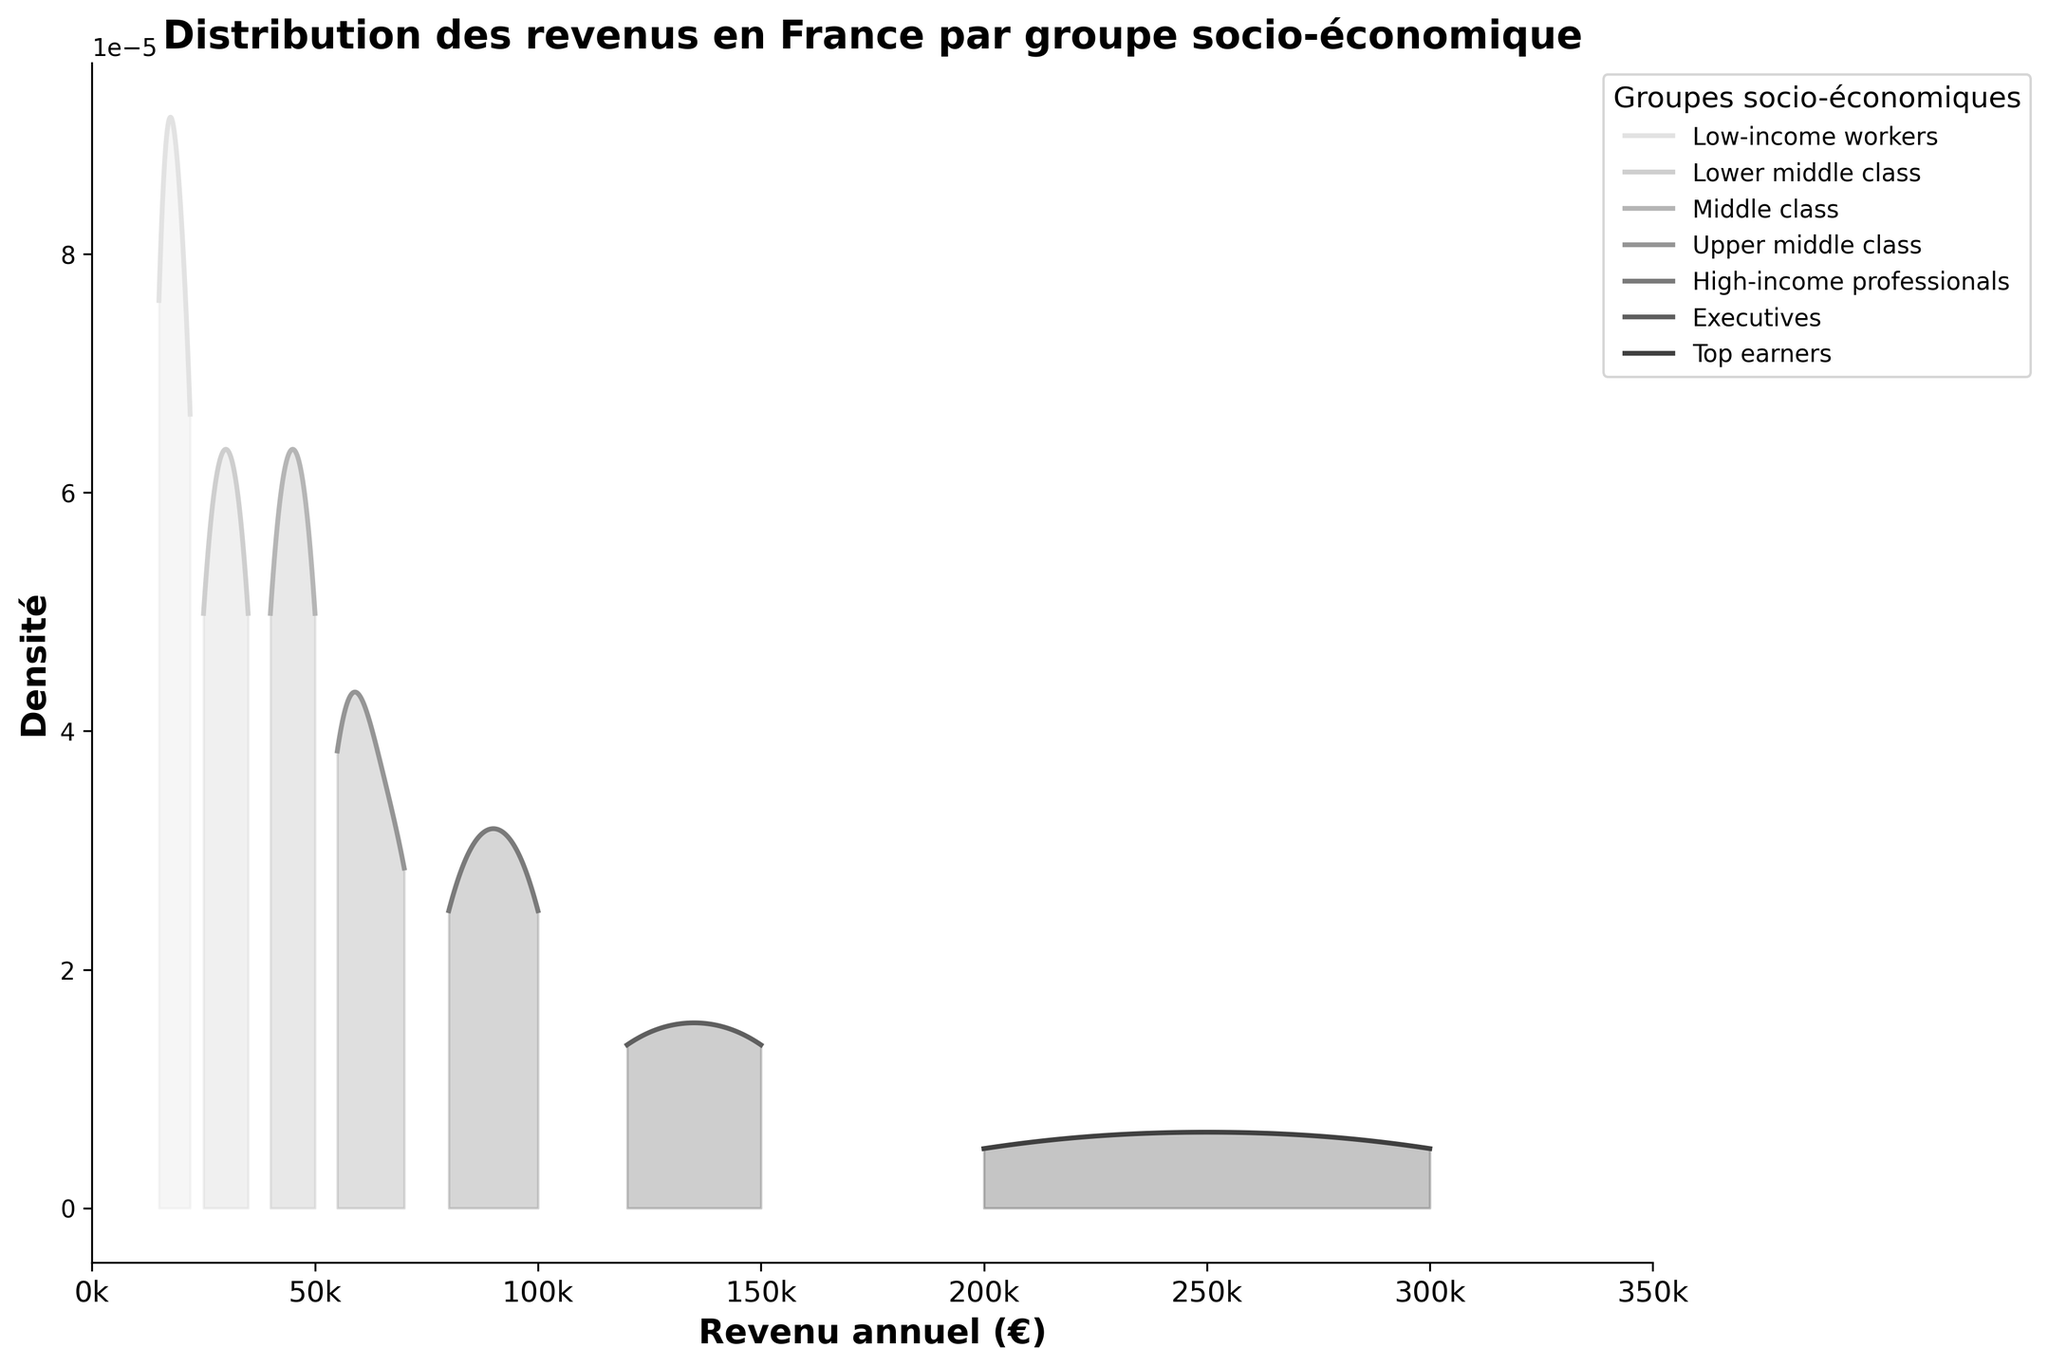What's the title of the plot? The title is located at the top of the plot, styled in bold and larger font. The title provides an overview of what the plot is representing.
Answer: Distribution des revenus en France par groupe socio-économique What is the range of the income axis in the plot? The x-axis represents income in euros, and its range can be identified by the values marked at the ends of the axis.
Answer: 0 to 350000 Which socioeconomic group appears to have the highest peak density? By observing the height of the peaks in the density curves for each group, the group with the highest peak density can be identified.
Answer: Lower middle class What groups have income densities that span above 200,000 euros? Look at the x-axis and identify which groups' density curves extend beyond the 200,000-euro mark.
Answer: Executives and Top earners How does the income distribution of 'Low-income workers' compare to 'Middle class'? Compare the shapes and positions of the density curves for these two groups. One should note where they start, peak, and end on the income axis.
Answer: 'Low-income workers' have lower income with the density curve peaking earlier and 'Middle class' have higher income distributions Which group has the widest income range? This can be determined by observing which group's density curve starts at the lowest and extends to the highest income values.
Answer: Top earners What is the median income for the 'High-income professionals' group? The median income of a group is the middle value of the income distribution, which can be found by identifying the center point of the density curve for that group.
Answer: 90,000 euros For which groups is the income density the narrowest? Examine the width of the density curves; the narrowest ones indicate groups with less variation in income.
Answer: Low-income workers and Middle class How many groups have their peak density before 100,000 euros? Count the number of curves that reach their highest point on the income axis before hitting the 100,000 euro mark.
Answer: Four groups What general trend can be observed regarding income and group label? Analyze the general positioning and shape of the density curves across all groups to identify any overarching patterns related to income distribution.
Answer: Higher socioeconomic groups have higher and wider income distributions 